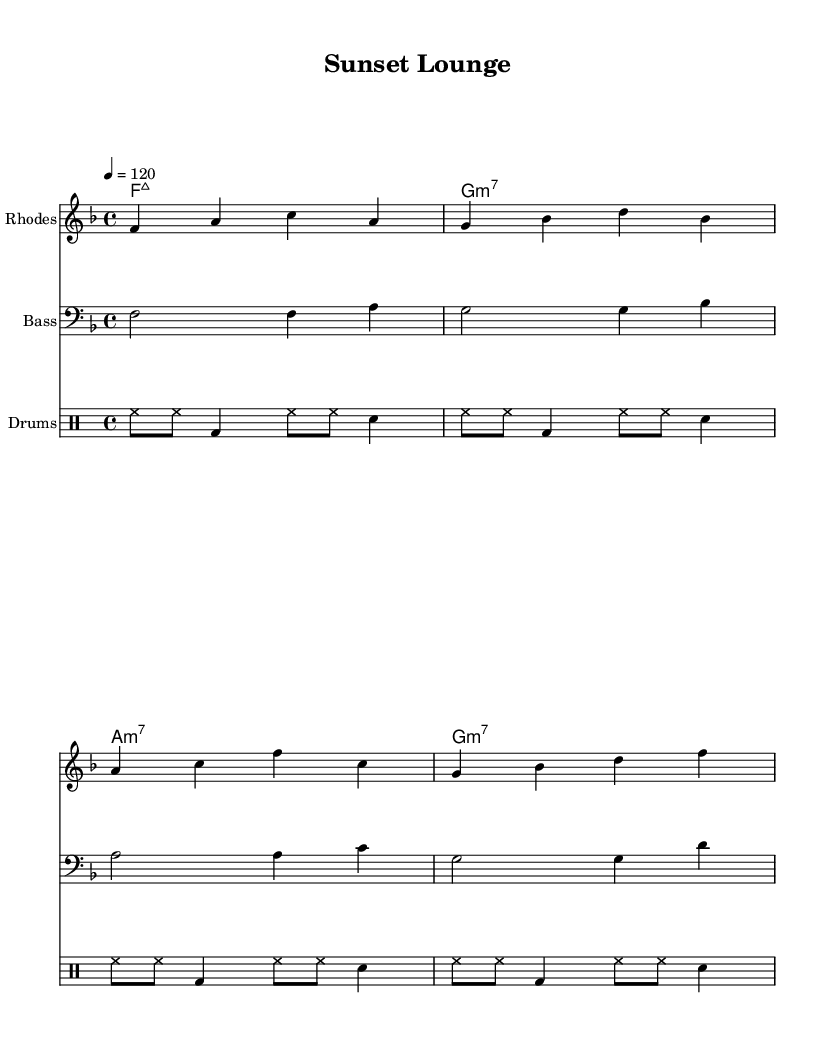What is the key signature of this music? The key signature shows one flat, which indicates F major. F major consists of the notes F, G, A, B♭, C, D, and E.
Answer: F major What is the time signature of this music? The time signature is indicated at the beginning, showing a 4/4 time signature. This means there are four beats in a measure and a quarter note receives one beat.
Answer: 4/4 What is the tempo marking for this piece? The tempo marking is indicated as quarter note equals 120, meaning the piece should be played at a moderate pace of 120 beats per minute.
Answer: 120 How many measures does the Rhodes part have? Counting the measures in the Rhodes part, there are four measures total. Each measure is separated by vertical lines, and they contain the notes played by the Rhodes keyboard.
Answer: Four What chords are used in this piece? The chords listed above the staff indicate F major 7, G minor 7, A minor 7, and G minor 7. These are typical chords used in a jazz and house context, contributing to the smooth sound.
Answer: F major 7, G minor 7, A minor 7 What type of rhythm pattern is indicated by the drum part? The drum part follows a typical house rhythm pattern with hi-hats, bass drum, and snare creating a consistent groove that supports the laid-back nature of the track. It alternates between closed hi-hats and snare hits on the backbeat.
Answer: House rhythm 